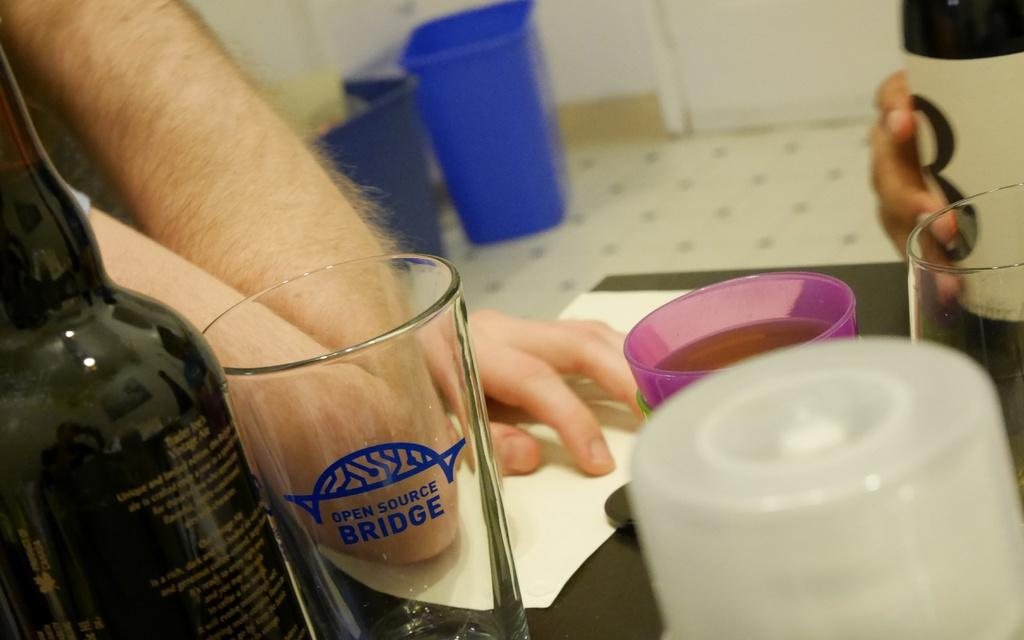Provide a one-sentence caption for the provided image. A person with their elbow on the table beside a glass with Open Source Bridge on it. 